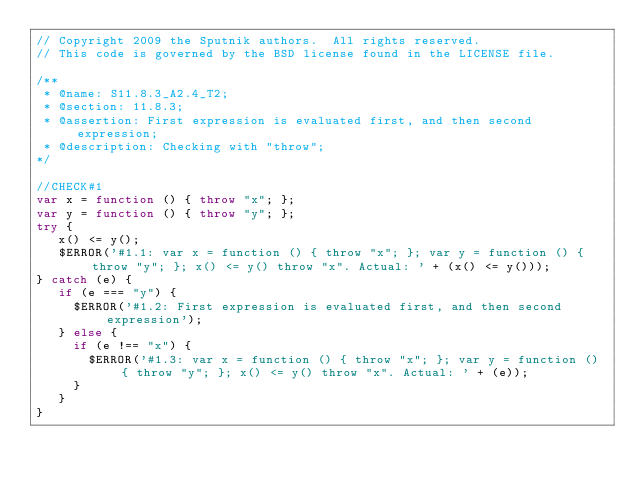<code> <loc_0><loc_0><loc_500><loc_500><_JavaScript_>// Copyright 2009 the Sputnik authors.  All rights reserved.
// This code is governed by the BSD license found in the LICENSE file.

/**
 * @name: S11.8.3_A2.4_T2;
 * @section: 11.8.3;
 * @assertion: First expression is evaluated first, and then second expression;
 * @description: Checking with "throw";
*/

//CHECK#1
var x = function () { throw "x"; };
var y = function () { throw "y"; };
try {
   x() <= y();
   $ERROR('#1.1: var x = function () { throw "x"; }; var y = function () { throw "y"; }; x() <= y() throw "x". Actual: ' + (x() <= y()));
} catch (e) {
   if (e === "y") {
     $ERROR('#1.2: First expression is evaluated first, and then second expression');
   } else {
     if (e !== "x") {
       $ERROR('#1.3: var x = function () { throw "x"; }; var y = function () { throw "y"; }; x() <= y() throw "x". Actual: ' + (e));
     }
   }
}
</code> 